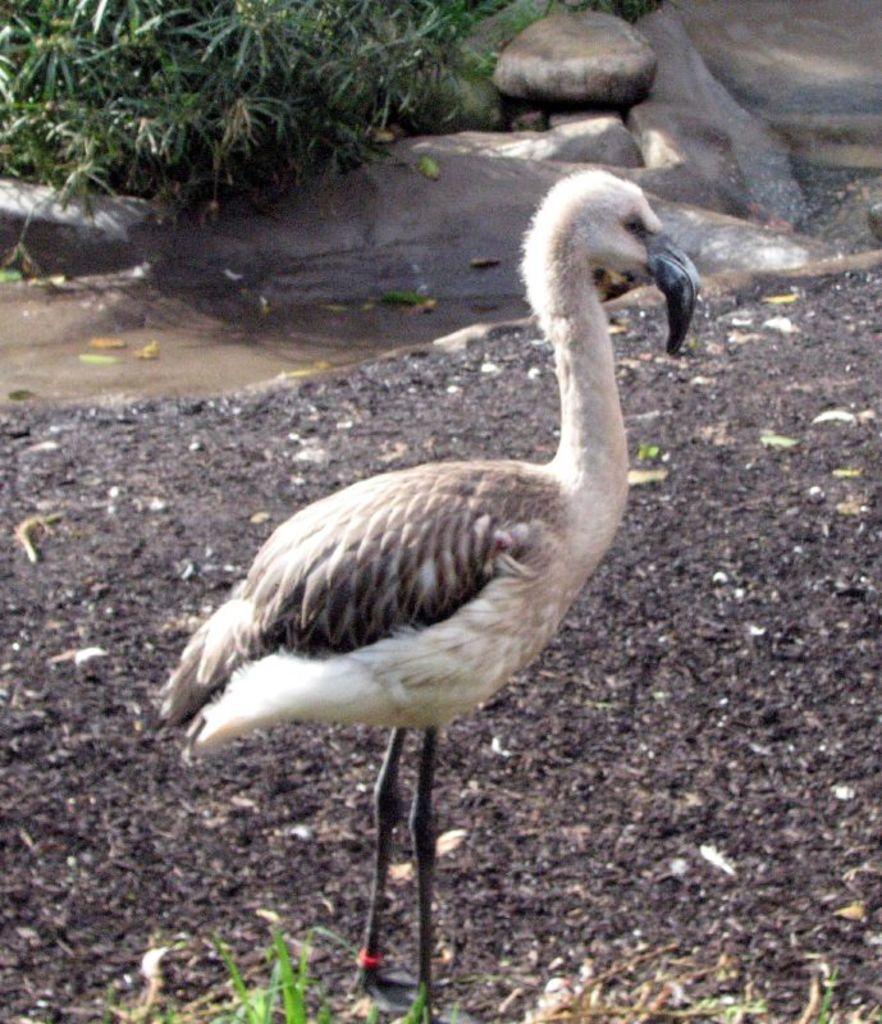In one or two sentences, can you explain what this image depicts? In this picture I can see a bird on the ground, side there are some rocks and plants. 